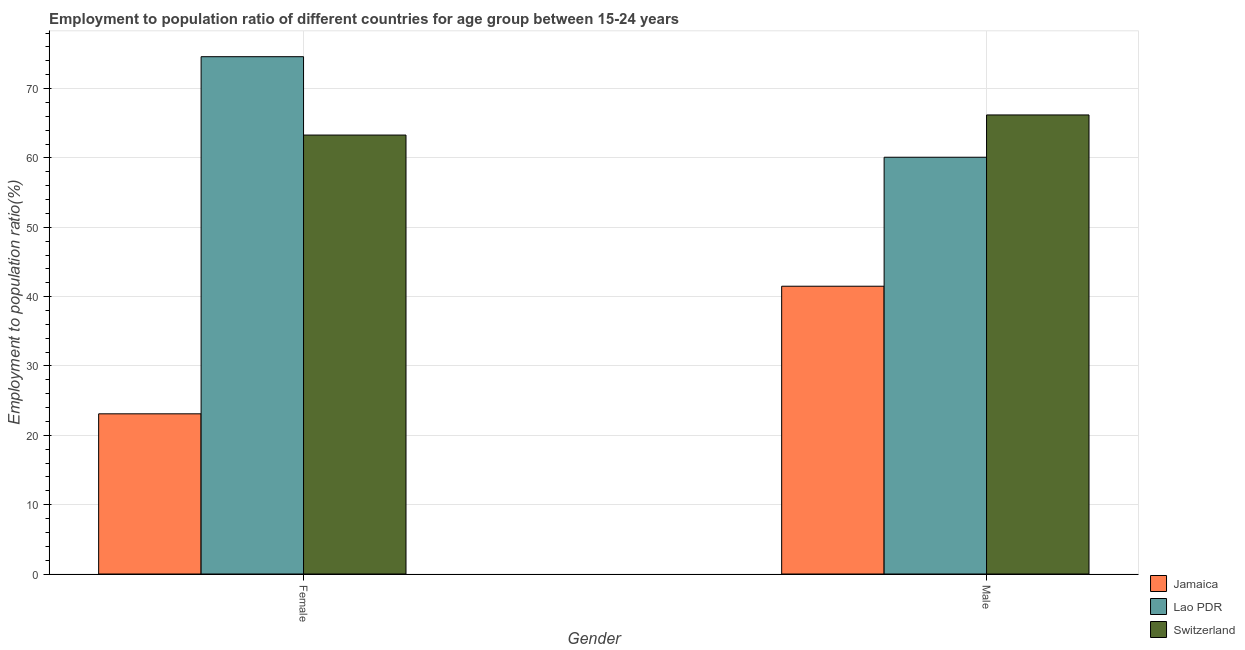How many different coloured bars are there?
Ensure brevity in your answer.  3. How many groups of bars are there?
Your response must be concise. 2. Are the number of bars per tick equal to the number of legend labels?
Keep it short and to the point. Yes. How many bars are there on the 1st tick from the left?
Your answer should be very brief. 3. What is the employment to population ratio(male) in Switzerland?
Give a very brief answer. 66.2. Across all countries, what is the maximum employment to population ratio(male)?
Provide a succinct answer. 66.2. Across all countries, what is the minimum employment to population ratio(female)?
Provide a short and direct response. 23.1. In which country was the employment to population ratio(female) maximum?
Offer a terse response. Lao PDR. In which country was the employment to population ratio(female) minimum?
Ensure brevity in your answer.  Jamaica. What is the total employment to population ratio(male) in the graph?
Offer a terse response. 167.8. What is the difference between the employment to population ratio(male) in Jamaica and that in Lao PDR?
Make the answer very short. -18.6. What is the difference between the employment to population ratio(male) in Switzerland and the employment to population ratio(female) in Lao PDR?
Ensure brevity in your answer.  -8.4. What is the average employment to population ratio(female) per country?
Give a very brief answer. 53.67. What is the difference between the employment to population ratio(male) and employment to population ratio(female) in Jamaica?
Make the answer very short. 18.4. What is the ratio of the employment to population ratio(male) in Jamaica to that in Lao PDR?
Keep it short and to the point. 0.69. Is the employment to population ratio(female) in Jamaica less than that in Lao PDR?
Offer a terse response. Yes. What does the 3rd bar from the left in Male represents?
Offer a terse response. Switzerland. What does the 2nd bar from the right in Female represents?
Provide a short and direct response. Lao PDR. How many bars are there?
Your answer should be compact. 6. How many countries are there in the graph?
Keep it short and to the point. 3. Are the values on the major ticks of Y-axis written in scientific E-notation?
Keep it short and to the point. No. Where does the legend appear in the graph?
Provide a succinct answer. Bottom right. How many legend labels are there?
Your response must be concise. 3. What is the title of the graph?
Give a very brief answer. Employment to population ratio of different countries for age group between 15-24 years. Does "Marshall Islands" appear as one of the legend labels in the graph?
Your answer should be very brief. No. What is the label or title of the Y-axis?
Keep it short and to the point. Employment to population ratio(%). What is the Employment to population ratio(%) of Jamaica in Female?
Your answer should be compact. 23.1. What is the Employment to population ratio(%) of Lao PDR in Female?
Your answer should be compact. 74.6. What is the Employment to population ratio(%) of Switzerland in Female?
Your response must be concise. 63.3. What is the Employment to population ratio(%) of Jamaica in Male?
Your answer should be very brief. 41.5. What is the Employment to population ratio(%) in Lao PDR in Male?
Keep it short and to the point. 60.1. What is the Employment to population ratio(%) of Switzerland in Male?
Give a very brief answer. 66.2. Across all Gender, what is the maximum Employment to population ratio(%) of Jamaica?
Your response must be concise. 41.5. Across all Gender, what is the maximum Employment to population ratio(%) of Lao PDR?
Ensure brevity in your answer.  74.6. Across all Gender, what is the maximum Employment to population ratio(%) in Switzerland?
Give a very brief answer. 66.2. Across all Gender, what is the minimum Employment to population ratio(%) in Jamaica?
Your response must be concise. 23.1. Across all Gender, what is the minimum Employment to population ratio(%) in Lao PDR?
Offer a very short reply. 60.1. Across all Gender, what is the minimum Employment to population ratio(%) in Switzerland?
Your answer should be compact. 63.3. What is the total Employment to population ratio(%) in Jamaica in the graph?
Make the answer very short. 64.6. What is the total Employment to population ratio(%) of Lao PDR in the graph?
Offer a very short reply. 134.7. What is the total Employment to population ratio(%) of Switzerland in the graph?
Ensure brevity in your answer.  129.5. What is the difference between the Employment to population ratio(%) in Jamaica in Female and that in Male?
Your answer should be very brief. -18.4. What is the difference between the Employment to population ratio(%) in Lao PDR in Female and that in Male?
Your answer should be very brief. 14.5. What is the difference between the Employment to population ratio(%) of Jamaica in Female and the Employment to population ratio(%) of Lao PDR in Male?
Provide a short and direct response. -37. What is the difference between the Employment to population ratio(%) in Jamaica in Female and the Employment to population ratio(%) in Switzerland in Male?
Your answer should be compact. -43.1. What is the average Employment to population ratio(%) of Jamaica per Gender?
Provide a short and direct response. 32.3. What is the average Employment to population ratio(%) in Lao PDR per Gender?
Your answer should be very brief. 67.35. What is the average Employment to population ratio(%) in Switzerland per Gender?
Provide a succinct answer. 64.75. What is the difference between the Employment to population ratio(%) of Jamaica and Employment to population ratio(%) of Lao PDR in Female?
Offer a terse response. -51.5. What is the difference between the Employment to population ratio(%) of Jamaica and Employment to population ratio(%) of Switzerland in Female?
Keep it short and to the point. -40.2. What is the difference between the Employment to population ratio(%) in Jamaica and Employment to population ratio(%) in Lao PDR in Male?
Give a very brief answer. -18.6. What is the difference between the Employment to population ratio(%) in Jamaica and Employment to population ratio(%) in Switzerland in Male?
Your answer should be very brief. -24.7. What is the difference between the Employment to population ratio(%) in Lao PDR and Employment to population ratio(%) in Switzerland in Male?
Your answer should be very brief. -6.1. What is the ratio of the Employment to population ratio(%) in Jamaica in Female to that in Male?
Your answer should be compact. 0.56. What is the ratio of the Employment to population ratio(%) in Lao PDR in Female to that in Male?
Your answer should be compact. 1.24. What is the ratio of the Employment to population ratio(%) of Switzerland in Female to that in Male?
Offer a very short reply. 0.96. What is the difference between the highest and the second highest Employment to population ratio(%) in Jamaica?
Offer a very short reply. 18.4. What is the difference between the highest and the second highest Employment to population ratio(%) of Lao PDR?
Your answer should be compact. 14.5. What is the difference between the highest and the lowest Employment to population ratio(%) in Lao PDR?
Your answer should be very brief. 14.5. What is the difference between the highest and the lowest Employment to population ratio(%) of Switzerland?
Your response must be concise. 2.9. 